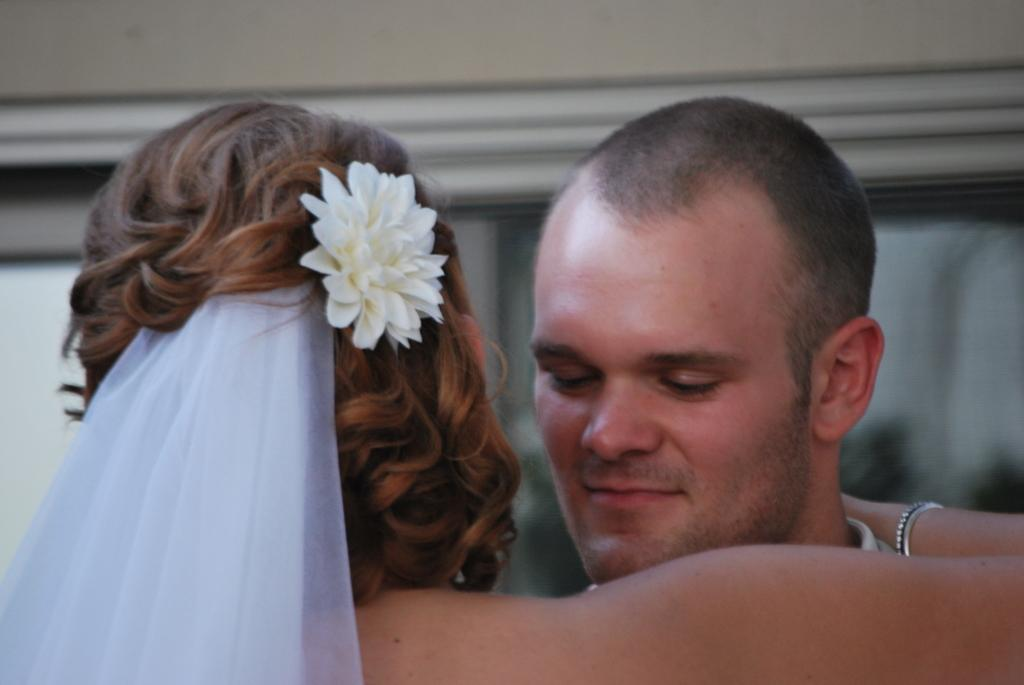How many people are in the image? There is a woman and a man in the image. What is the woman doing to the man? The woman is hugging the man. What can be seen on the woman's head? The woman has a white color flower and a scarf on her head. What is visible in the background of the image? There is a wall and glass in the background of the image. What type of nut can be seen on the ground in the image? There is no nut visible on the ground in the image. How does the pollution affect the scene in the image? There is no mention of pollution in the image, so it cannot be determined how it affects the scene. 